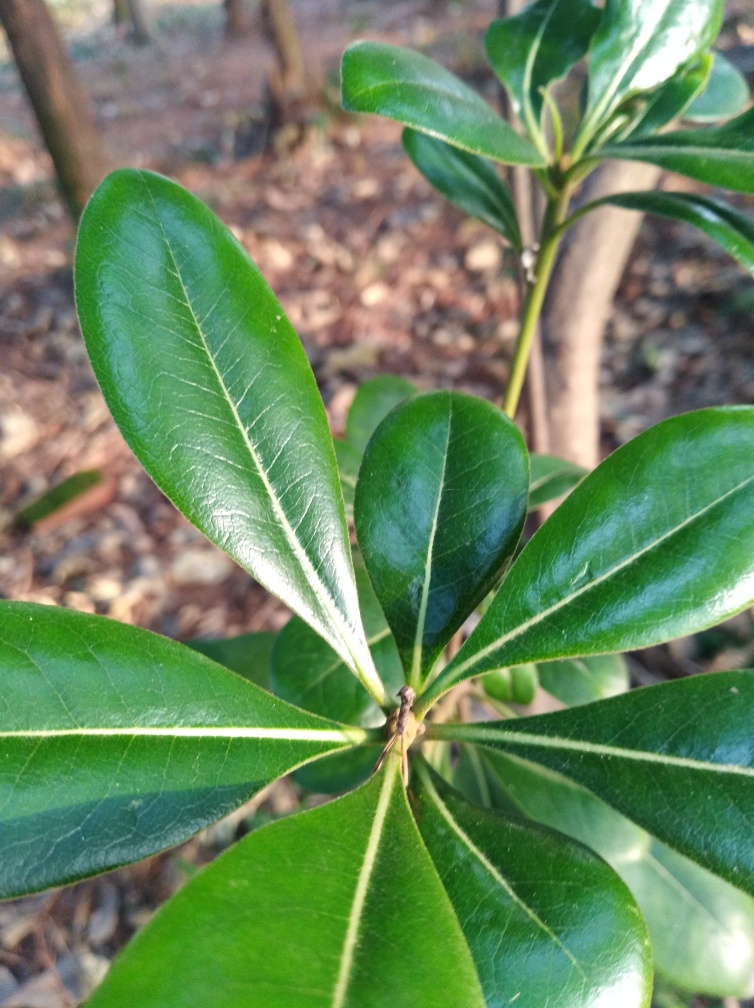Are there any quality issues related to underexposure? The image appears well-lit with no indication of underexposure. The leaves show clear, vibrant colors and distinct textures, which would likely be muted or obscured if the image was underexposed. 